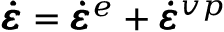<formula> <loc_0><loc_0><loc_500><loc_500>\pm b { \dot { \varepsilon } } = \pm b { \dot { \varepsilon } } ^ { e } + \pm b { \dot { \varepsilon } } ^ { v p }</formula> 